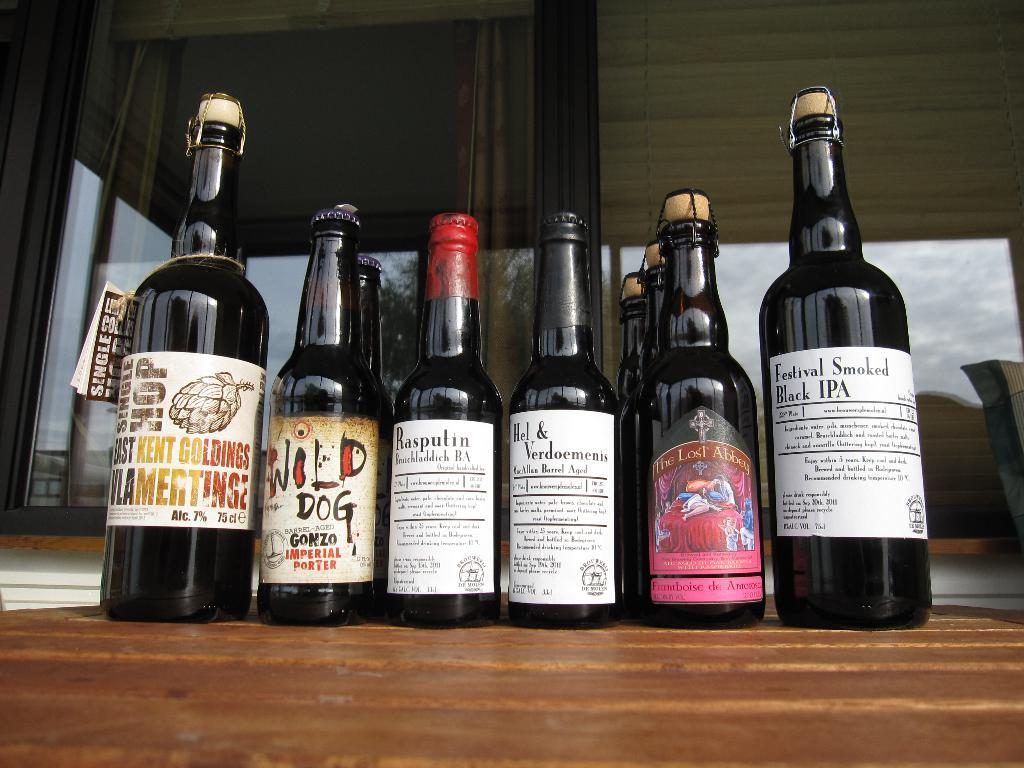Provide a one-sentence caption for the provided image. the word black is on one of the bottles. 